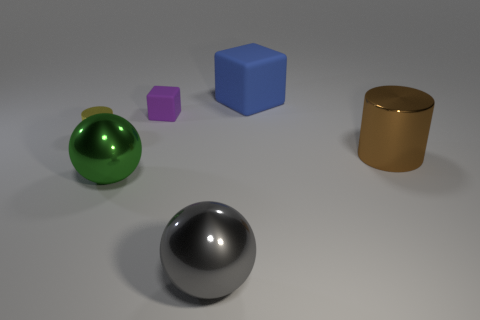What number of things are both on the right side of the green thing and behind the green object? Upon examining the image, it can be observed that there are two items situated on the right side of the green spherical object, as well as being positioned behind it. These are the purple cube and the blue cube. 